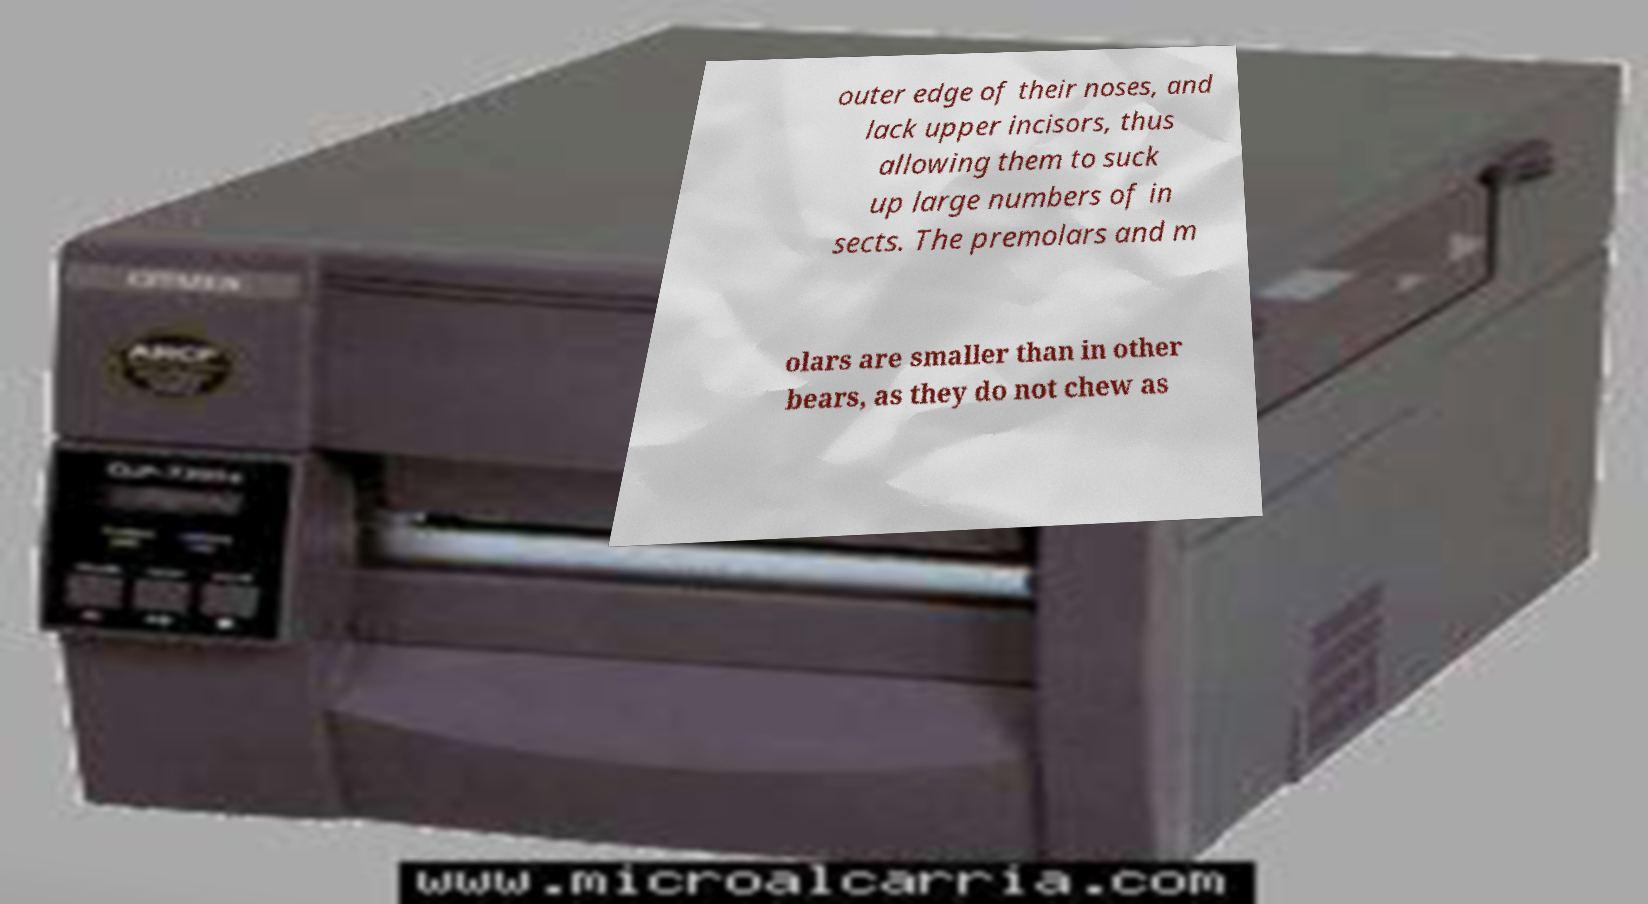Please read and relay the text visible in this image. What does it say? outer edge of their noses, and lack upper incisors, thus allowing them to suck up large numbers of in sects. The premolars and m olars are smaller than in other bears, as they do not chew as 